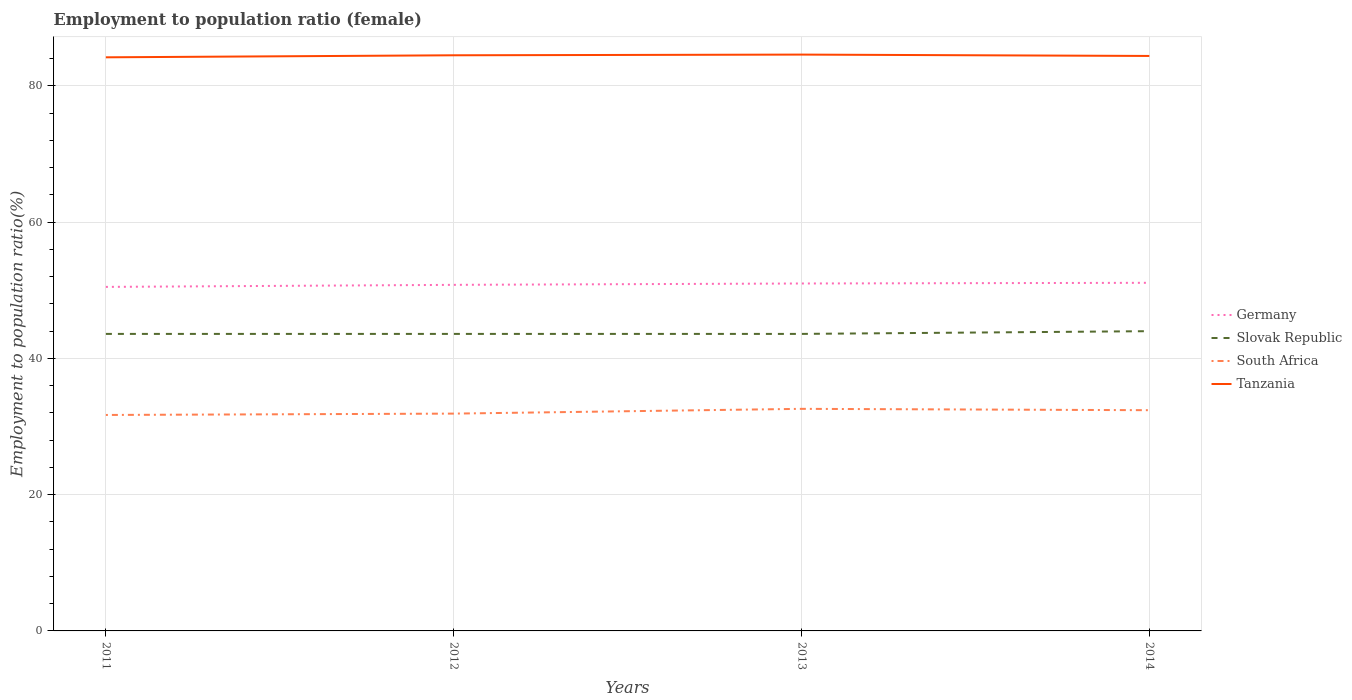Does the line corresponding to Slovak Republic intersect with the line corresponding to South Africa?
Offer a terse response. No. Is the number of lines equal to the number of legend labels?
Your answer should be compact. Yes. Across all years, what is the maximum employment to population ratio in Germany?
Give a very brief answer. 50.5. What is the total employment to population ratio in Slovak Republic in the graph?
Offer a very short reply. 0. What is the difference between the highest and the second highest employment to population ratio in Slovak Republic?
Provide a succinct answer. 0.4. How many years are there in the graph?
Offer a very short reply. 4. Does the graph contain any zero values?
Provide a succinct answer. No. Does the graph contain grids?
Your response must be concise. Yes. How many legend labels are there?
Keep it short and to the point. 4. How are the legend labels stacked?
Offer a very short reply. Vertical. What is the title of the graph?
Ensure brevity in your answer.  Employment to population ratio (female). Does "Middle East & North Africa (all income levels)" appear as one of the legend labels in the graph?
Provide a succinct answer. No. What is the Employment to population ratio(%) in Germany in 2011?
Make the answer very short. 50.5. What is the Employment to population ratio(%) in Slovak Republic in 2011?
Offer a terse response. 43.6. What is the Employment to population ratio(%) of South Africa in 2011?
Your response must be concise. 31.7. What is the Employment to population ratio(%) in Tanzania in 2011?
Your answer should be compact. 84.2. What is the Employment to population ratio(%) of Germany in 2012?
Make the answer very short. 50.8. What is the Employment to population ratio(%) in Slovak Republic in 2012?
Keep it short and to the point. 43.6. What is the Employment to population ratio(%) in South Africa in 2012?
Keep it short and to the point. 31.9. What is the Employment to population ratio(%) of Tanzania in 2012?
Keep it short and to the point. 84.5. What is the Employment to population ratio(%) in Slovak Republic in 2013?
Offer a very short reply. 43.6. What is the Employment to population ratio(%) of South Africa in 2013?
Make the answer very short. 32.6. What is the Employment to population ratio(%) in Tanzania in 2013?
Offer a terse response. 84.6. What is the Employment to population ratio(%) of Germany in 2014?
Your answer should be very brief. 51.1. What is the Employment to population ratio(%) in Slovak Republic in 2014?
Your answer should be compact. 44. What is the Employment to population ratio(%) in South Africa in 2014?
Make the answer very short. 32.4. What is the Employment to population ratio(%) in Tanzania in 2014?
Keep it short and to the point. 84.4. Across all years, what is the maximum Employment to population ratio(%) in Germany?
Provide a short and direct response. 51.1. Across all years, what is the maximum Employment to population ratio(%) of South Africa?
Keep it short and to the point. 32.6. Across all years, what is the maximum Employment to population ratio(%) of Tanzania?
Your response must be concise. 84.6. Across all years, what is the minimum Employment to population ratio(%) of Germany?
Provide a succinct answer. 50.5. Across all years, what is the minimum Employment to population ratio(%) of Slovak Republic?
Offer a terse response. 43.6. Across all years, what is the minimum Employment to population ratio(%) of South Africa?
Provide a succinct answer. 31.7. Across all years, what is the minimum Employment to population ratio(%) in Tanzania?
Your response must be concise. 84.2. What is the total Employment to population ratio(%) of Germany in the graph?
Offer a terse response. 203.4. What is the total Employment to population ratio(%) in Slovak Republic in the graph?
Ensure brevity in your answer.  174.8. What is the total Employment to population ratio(%) of South Africa in the graph?
Your response must be concise. 128.6. What is the total Employment to population ratio(%) in Tanzania in the graph?
Offer a terse response. 337.7. What is the difference between the Employment to population ratio(%) of Germany in 2011 and that in 2012?
Your answer should be very brief. -0.3. What is the difference between the Employment to population ratio(%) in Tanzania in 2011 and that in 2012?
Your answer should be very brief. -0.3. What is the difference between the Employment to population ratio(%) of Slovak Republic in 2011 and that in 2013?
Keep it short and to the point. 0. What is the difference between the Employment to population ratio(%) of South Africa in 2011 and that in 2013?
Keep it short and to the point. -0.9. What is the difference between the Employment to population ratio(%) of South Africa in 2011 and that in 2014?
Make the answer very short. -0.7. What is the difference between the Employment to population ratio(%) of Germany in 2012 and that in 2013?
Make the answer very short. -0.2. What is the difference between the Employment to population ratio(%) of South Africa in 2012 and that in 2013?
Offer a terse response. -0.7. What is the difference between the Employment to population ratio(%) in Tanzania in 2012 and that in 2013?
Your answer should be compact. -0.1. What is the difference between the Employment to population ratio(%) of South Africa in 2012 and that in 2014?
Offer a terse response. -0.5. What is the difference between the Employment to population ratio(%) in Tanzania in 2013 and that in 2014?
Provide a short and direct response. 0.2. What is the difference between the Employment to population ratio(%) in Germany in 2011 and the Employment to population ratio(%) in Tanzania in 2012?
Your response must be concise. -34. What is the difference between the Employment to population ratio(%) in Slovak Republic in 2011 and the Employment to population ratio(%) in Tanzania in 2012?
Ensure brevity in your answer.  -40.9. What is the difference between the Employment to population ratio(%) of South Africa in 2011 and the Employment to population ratio(%) of Tanzania in 2012?
Provide a succinct answer. -52.8. What is the difference between the Employment to population ratio(%) in Germany in 2011 and the Employment to population ratio(%) in Slovak Republic in 2013?
Give a very brief answer. 6.9. What is the difference between the Employment to population ratio(%) of Germany in 2011 and the Employment to population ratio(%) of South Africa in 2013?
Provide a succinct answer. 17.9. What is the difference between the Employment to population ratio(%) in Germany in 2011 and the Employment to population ratio(%) in Tanzania in 2013?
Keep it short and to the point. -34.1. What is the difference between the Employment to population ratio(%) of Slovak Republic in 2011 and the Employment to population ratio(%) of Tanzania in 2013?
Provide a succinct answer. -41. What is the difference between the Employment to population ratio(%) of South Africa in 2011 and the Employment to population ratio(%) of Tanzania in 2013?
Your response must be concise. -52.9. What is the difference between the Employment to population ratio(%) of Germany in 2011 and the Employment to population ratio(%) of Slovak Republic in 2014?
Offer a terse response. 6.5. What is the difference between the Employment to population ratio(%) of Germany in 2011 and the Employment to population ratio(%) of South Africa in 2014?
Make the answer very short. 18.1. What is the difference between the Employment to population ratio(%) in Germany in 2011 and the Employment to population ratio(%) in Tanzania in 2014?
Your answer should be very brief. -33.9. What is the difference between the Employment to population ratio(%) of Slovak Republic in 2011 and the Employment to population ratio(%) of Tanzania in 2014?
Give a very brief answer. -40.8. What is the difference between the Employment to population ratio(%) in South Africa in 2011 and the Employment to population ratio(%) in Tanzania in 2014?
Your answer should be very brief. -52.7. What is the difference between the Employment to population ratio(%) of Germany in 2012 and the Employment to population ratio(%) of Slovak Republic in 2013?
Offer a very short reply. 7.2. What is the difference between the Employment to population ratio(%) in Germany in 2012 and the Employment to population ratio(%) in South Africa in 2013?
Offer a terse response. 18.2. What is the difference between the Employment to population ratio(%) in Germany in 2012 and the Employment to population ratio(%) in Tanzania in 2013?
Offer a terse response. -33.8. What is the difference between the Employment to population ratio(%) in Slovak Republic in 2012 and the Employment to population ratio(%) in South Africa in 2013?
Give a very brief answer. 11. What is the difference between the Employment to population ratio(%) of Slovak Republic in 2012 and the Employment to population ratio(%) of Tanzania in 2013?
Keep it short and to the point. -41. What is the difference between the Employment to population ratio(%) in South Africa in 2012 and the Employment to population ratio(%) in Tanzania in 2013?
Your answer should be compact. -52.7. What is the difference between the Employment to population ratio(%) of Germany in 2012 and the Employment to population ratio(%) of Slovak Republic in 2014?
Ensure brevity in your answer.  6.8. What is the difference between the Employment to population ratio(%) in Germany in 2012 and the Employment to population ratio(%) in Tanzania in 2014?
Provide a short and direct response. -33.6. What is the difference between the Employment to population ratio(%) in Slovak Republic in 2012 and the Employment to population ratio(%) in Tanzania in 2014?
Offer a terse response. -40.8. What is the difference between the Employment to population ratio(%) of South Africa in 2012 and the Employment to population ratio(%) of Tanzania in 2014?
Your response must be concise. -52.5. What is the difference between the Employment to population ratio(%) of Germany in 2013 and the Employment to population ratio(%) of Slovak Republic in 2014?
Offer a terse response. 7. What is the difference between the Employment to population ratio(%) of Germany in 2013 and the Employment to population ratio(%) of South Africa in 2014?
Your answer should be very brief. 18.6. What is the difference between the Employment to population ratio(%) in Germany in 2013 and the Employment to population ratio(%) in Tanzania in 2014?
Make the answer very short. -33.4. What is the difference between the Employment to population ratio(%) in Slovak Republic in 2013 and the Employment to population ratio(%) in South Africa in 2014?
Provide a succinct answer. 11.2. What is the difference between the Employment to population ratio(%) in Slovak Republic in 2013 and the Employment to population ratio(%) in Tanzania in 2014?
Keep it short and to the point. -40.8. What is the difference between the Employment to population ratio(%) in South Africa in 2013 and the Employment to population ratio(%) in Tanzania in 2014?
Provide a short and direct response. -51.8. What is the average Employment to population ratio(%) of Germany per year?
Your answer should be very brief. 50.85. What is the average Employment to population ratio(%) in Slovak Republic per year?
Your answer should be very brief. 43.7. What is the average Employment to population ratio(%) of South Africa per year?
Make the answer very short. 32.15. What is the average Employment to population ratio(%) in Tanzania per year?
Provide a succinct answer. 84.42. In the year 2011, what is the difference between the Employment to population ratio(%) of Germany and Employment to population ratio(%) of Slovak Republic?
Your answer should be very brief. 6.9. In the year 2011, what is the difference between the Employment to population ratio(%) of Germany and Employment to population ratio(%) of South Africa?
Your response must be concise. 18.8. In the year 2011, what is the difference between the Employment to population ratio(%) in Germany and Employment to population ratio(%) in Tanzania?
Provide a succinct answer. -33.7. In the year 2011, what is the difference between the Employment to population ratio(%) in Slovak Republic and Employment to population ratio(%) in South Africa?
Offer a very short reply. 11.9. In the year 2011, what is the difference between the Employment to population ratio(%) in Slovak Republic and Employment to population ratio(%) in Tanzania?
Provide a short and direct response. -40.6. In the year 2011, what is the difference between the Employment to population ratio(%) in South Africa and Employment to population ratio(%) in Tanzania?
Your answer should be very brief. -52.5. In the year 2012, what is the difference between the Employment to population ratio(%) of Germany and Employment to population ratio(%) of Tanzania?
Your response must be concise. -33.7. In the year 2012, what is the difference between the Employment to population ratio(%) of Slovak Republic and Employment to population ratio(%) of South Africa?
Make the answer very short. 11.7. In the year 2012, what is the difference between the Employment to population ratio(%) of Slovak Republic and Employment to population ratio(%) of Tanzania?
Keep it short and to the point. -40.9. In the year 2012, what is the difference between the Employment to population ratio(%) in South Africa and Employment to population ratio(%) in Tanzania?
Offer a very short reply. -52.6. In the year 2013, what is the difference between the Employment to population ratio(%) in Germany and Employment to population ratio(%) in South Africa?
Give a very brief answer. 18.4. In the year 2013, what is the difference between the Employment to population ratio(%) in Germany and Employment to population ratio(%) in Tanzania?
Offer a terse response. -33.6. In the year 2013, what is the difference between the Employment to population ratio(%) in Slovak Republic and Employment to population ratio(%) in South Africa?
Your answer should be very brief. 11. In the year 2013, what is the difference between the Employment to population ratio(%) of Slovak Republic and Employment to population ratio(%) of Tanzania?
Your response must be concise. -41. In the year 2013, what is the difference between the Employment to population ratio(%) in South Africa and Employment to population ratio(%) in Tanzania?
Provide a succinct answer. -52. In the year 2014, what is the difference between the Employment to population ratio(%) of Germany and Employment to population ratio(%) of Tanzania?
Your answer should be compact. -33.3. In the year 2014, what is the difference between the Employment to population ratio(%) in Slovak Republic and Employment to population ratio(%) in South Africa?
Your answer should be compact. 11.6. In the year 2014, what is the difference between the Employment to population ratio(%) in Slovak Republic and Employment to population ratio(%) in Tanzania?
Offer a very short reply. -40.4. In the year 2014, what is the difference between the Employment to population ratio(%) of South Africa and Employment to population ratio(%) of Tanzania?
Your response must be concise. -52. What is the ratio of the Employment to population ratio(%) of Germany in 2011 to that in 2012?
Offer a terse response. 0.99. What is the ratio of the Employment to population ratio(%) in South Africa in 2011 to that in 2012?
Your response must be concise. 0.99. What is the ratio of the Employment to population ratio(%) in Germany in 2011 to that in 2013?
Ensure brevity in your answer.  0.99. What is the ratio of the Employment to population ratio(%) of Slovak Republic in 2011 to that in 2013?
Ensure brevity in your answer.  1. What is the ratio of the Employment to population ratio(%) of South Africa in 2011 to that in 2013?
Offer a very short reply. 0.97. What is the ratio of the Employment to population ratio(%) of Germany in 2011 to that in 2014?
Offer a very short reply. 0.99. What is the ratio of the Employment to population ratio(%) of Slovak Republic in 2011 to that in 2014?
Keep it short and to the point. 0.99. What is the ratio of the Employment to population ratio(%) in South Africa in 2011 to that in 2014?
Offer a very short reply. 0.98. What is the ratio of the Employment to population ratio(%) in Slovak Republic in 2012 to that in 2013?
Your answer should be compact. 1. What is the ratio of the Employment to population ratio(%) in South Africa in 2012 to that in 2013?
Provide a short and direct response. 0.98. What is the ratio of the Employment to population ratio(%) of Tanzania in 2012 to that in 2013?
Your response must be concise. 1. What is the ratio of the Employment to population ratio(%) of Germany in 2012 to that in 2014?
Offer a very short reply. 0.99. What is the ratio of the Employment to population ratio(%) of Slovak Republic in 2012 to that in 2014?
Offer a very short reply. 0.99. What is the ratio of the Employment to population ratio(%) in South Africa in 2012 to that in 2014?
Give a very brief answer. 0.98. What is the ratio of the Employment to population ratio(%) of Germany in 2013 to that in 2014?
Your answer should be very brief. 1. What is the ratio of the Employment to population ratio(%) of Slovak Republic in 2013 to that in 2014?
Keep it short and to the point. 0.99. What is the ratio of the Employment to population ratio(%) of South Africa in 2013 to that in 2014?
Offer a very short reply. 1.01. What is the ratio of the Employment to population ratio(%) in Tanzania in 2013 to that in 2014?
Your answer should be very brief. 1. What is the difference between the highest and the lowest Employment to population ratio(%) of Slovak Republic?
Ensure brevity in your answer.  0.4. 